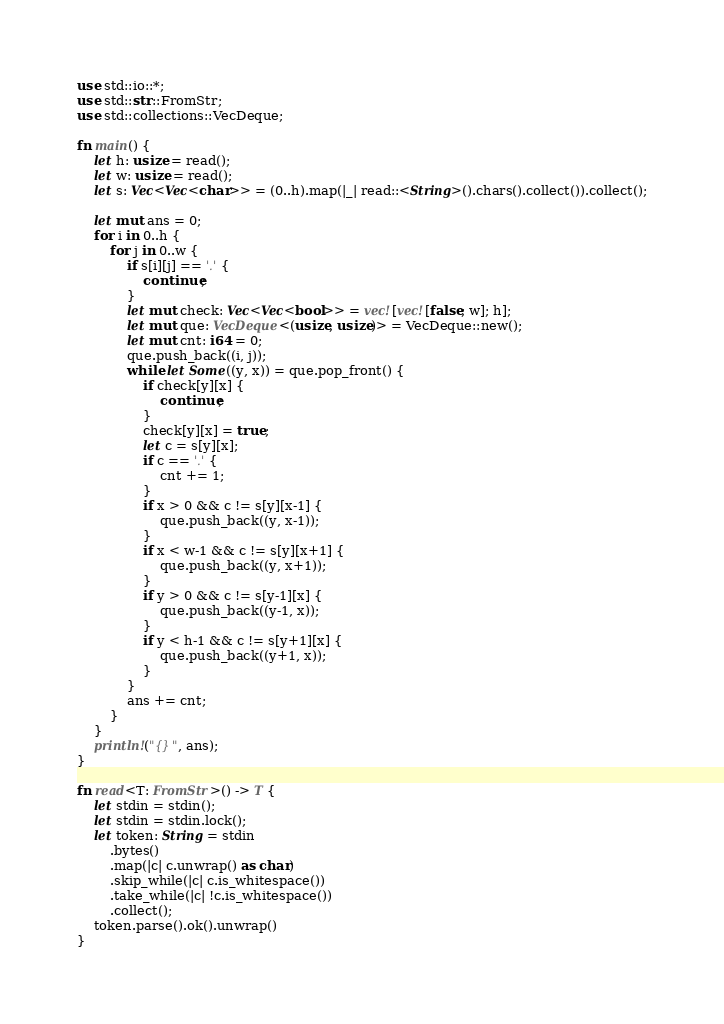Convert code to text. <code><loc_0><loc_0><loc_500><loc_500><_Rust_>use std::io::*;
use std::str::FromStr;
use std::collections::VecDeque;

fn main() {
    let h: usize = read();
    let w: usize = read();
    let s: Vec<Vec<char>> = (0..h).map(|_| read::<String>().chars().collect()).collect();

    let mut ans = 0;
    for i in 0..h {
        for j in 0..w {
            if s[i][j] == '.' {
                continue;
            }
            let mut check: Vec<Vec<bool>> = vec![vec![false; w]; h];
            let mut que: VecDeque<(usize, usize)> = VecDeque::new();
            let mut cnt: i64 = 0;
            que.push_back((i, j));
            while let Some((y, x)) = que.pop_front() {
                if check[y][x] {
                    continue;
                }
                check[y][x] = true;
                let c = s[y][x];
                if c == '.' {
                    cnt += 1;
                }
                if x > 0 && c != s[y][x-1] {
                    que.push_back((y, x-1));
                }
                if x < w-1 && c != s[y][x+1] {
                    que.push_back((y, x+1));
                }
                if y > 0 && c != s[y-1][x] {
                    que.push_back((y-1, x));
                }
                if y < h-1 && c != s[y+1][x] {
                    que.push_back((y+1, x));
                }
            }
            ans += cnt;
        }
    }
    println!("{}", ans);
}

fn read<T: FromStr>() -> T {
    let stdin = stdin();
    let stdin = stdin.lock();
    let token: String = stdin
        .bytes()
        .map(|c| c.unwrap() as char)
        .skip_while(|c| c.is_whitespace())
        .take_while(|c| !c.is_whitespace())
        .collect();
    token.parse().ok().unwrap()
}
</code> 